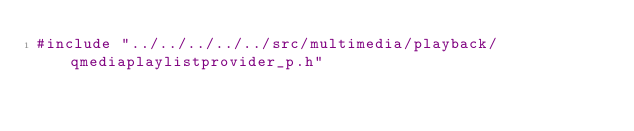<code> <loc_0><loc_0><loc_500><loc_500><_C_>#include "../../../../../src/multimedia/playback/qmediaplaylistprovider_p.h"
</code> 